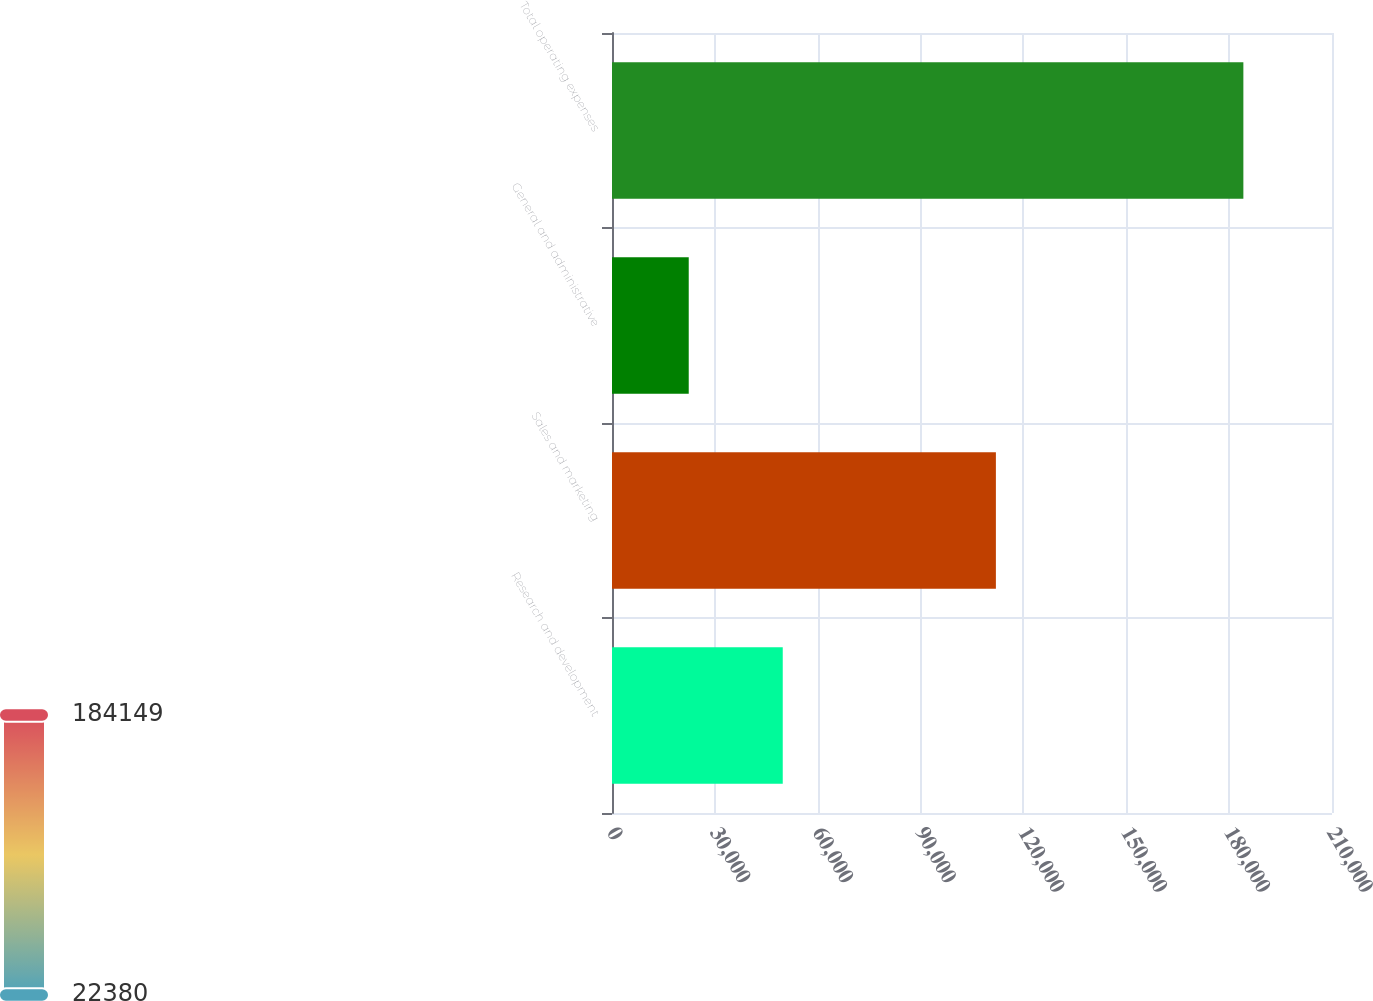<chart> <loc_0><loc_0><loc_500><loc_500><bar_chart><fcel>Research and development<fcel>Sales and marketing<fcel>General and administrative<fcel>Total operating expenses<nl><fcel>49801<fcel>111968<fcel>22380<fcel>184149<nl></chart> 